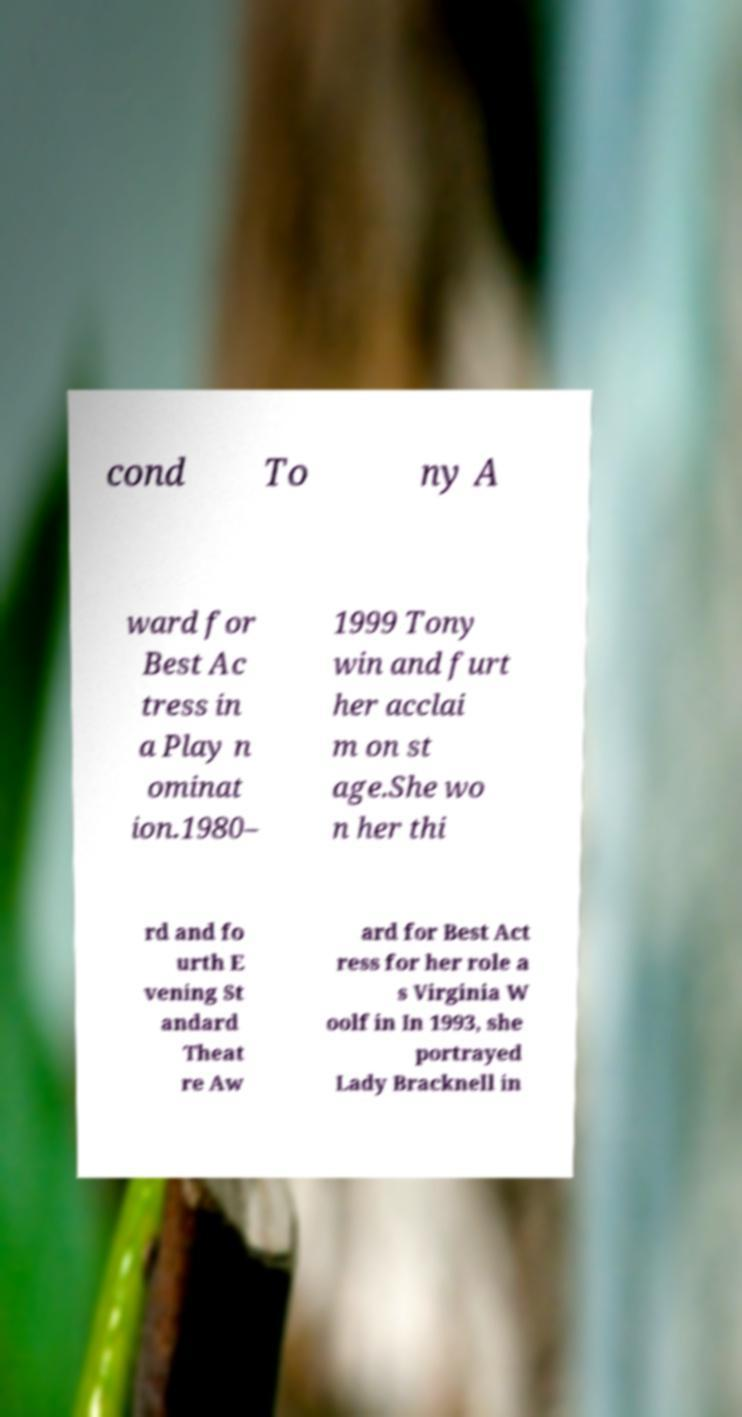Can you read and provide the text displayed in the image?This photo seems to have some interesting text. Can you extract and type it out for me? cond To ny A ward for Best Ac tress in a Play n ominat ion.1980– 1999 Tony win and furt her acclai m on st age.She wo n her thi rd and fo urth E vening St andard Theat re Aw ard for Best Act ress for her role a s Virginia W oolf in In 1993, she portrayed Lady Bracknell in 